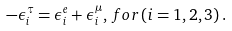<formula> <loc_0><loc_0><loc_500><loc_500>- \epsilon _ { i } ^ { \tau } = \epsilon _ { i } ^ { e } + \epsilon _ { i } ^ { \mu } , \, f o r \, ( i = 1 , 2 , 3 ) \, .</formula> 